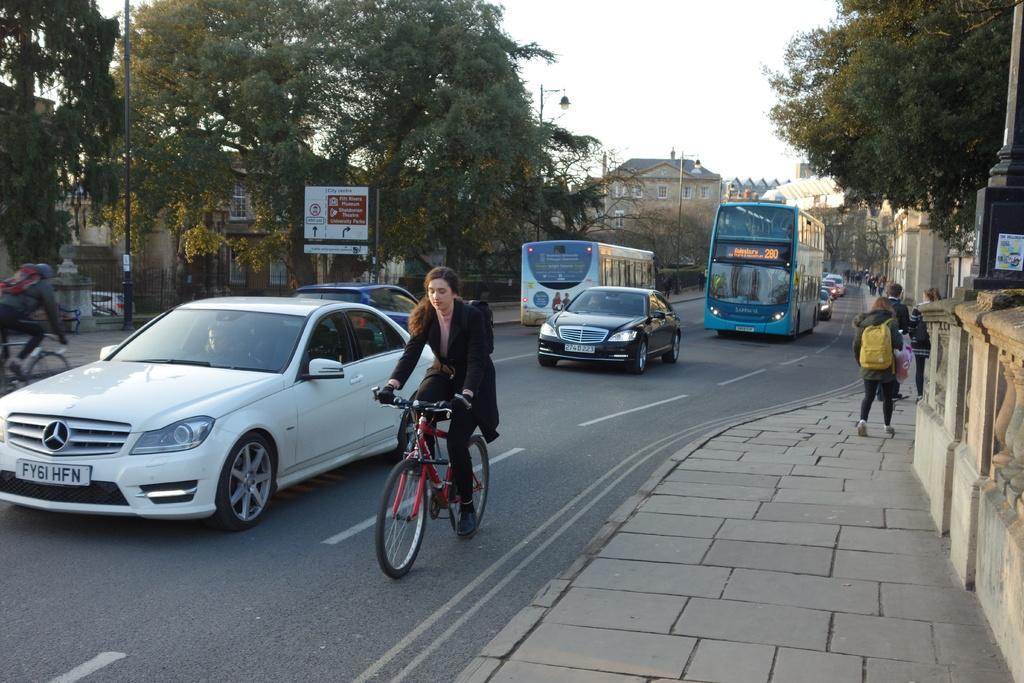Could you give a brief overview of what you see in this image? In this image there are vehicles on the road, two persons riding bicycles, on the right side there is a footpath, on that footpath people are walking, in the top right there is a tree, in the background there are trees, buildings, sign board and a sky. 